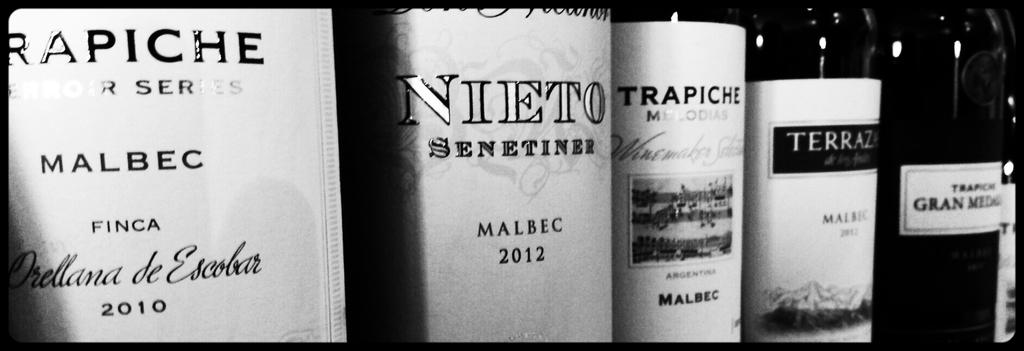<image>
Share a concise interpretation of the image provided. a Nieto bottle that is among many other ones 